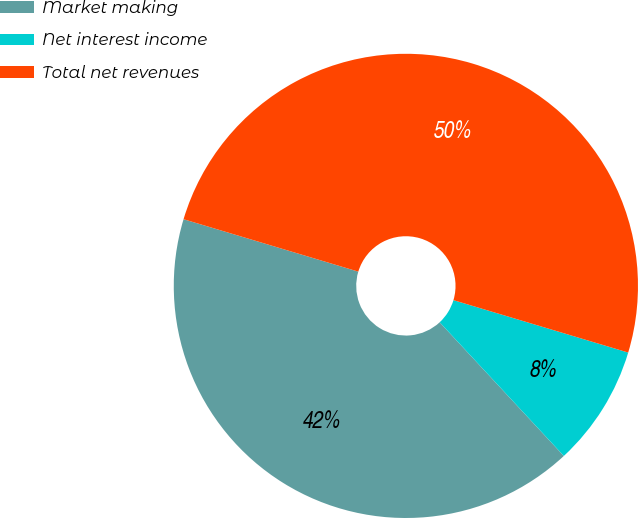Convert chart to OTSL. <chart><loc_0><loc_0><loc_500><loc_500><pie_chart><fcel>Market making<fcel>Net interest income<fcel>Total net revenues<nl><fcel>41.55%<fcel>8.45%<fcel>50.0%<nl></chart> 